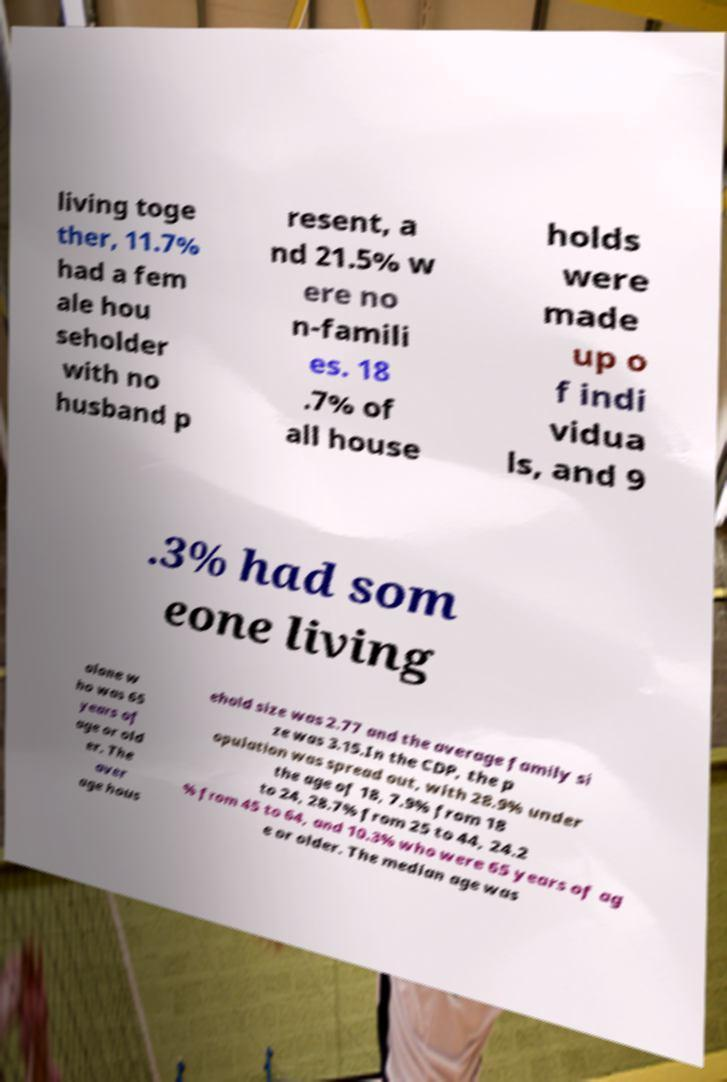I need the written content from this picture converted into text. Can you do that? living toge ther, 11.7% had a fem ale hou seholder with no husband p resent, a nd 21.5% w ere no n-famili es. 18 .7% of all house holds were made up o f indi vidua ls, and 9 .3% had som eone living alone w ho was 65 years of age or old er. The aver age hous ehold size was 2.77 and the average family si ze was 3.15.In the CDP, the p opulation was spread out, with 28.9% under the age of 18, 7.9% from 18 to 24, 28.7% from 25 to 44, 24.2 % from 45 to 64, and 10.3% who were 65 years of ag e or older. The median age was 